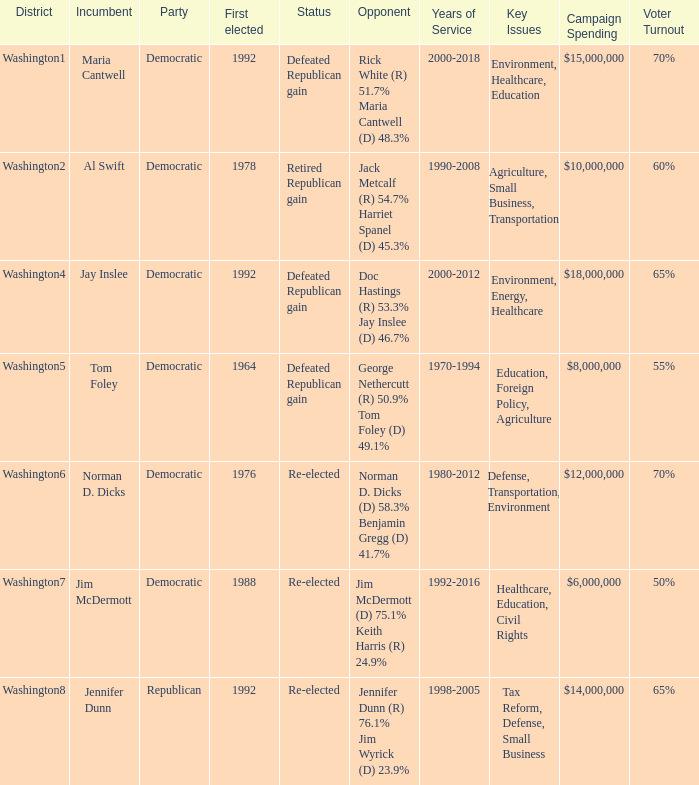What was the result of the election of doc hastings (r) 53.3% jay inslee (d) 46.7% Defeated Republican gain. 